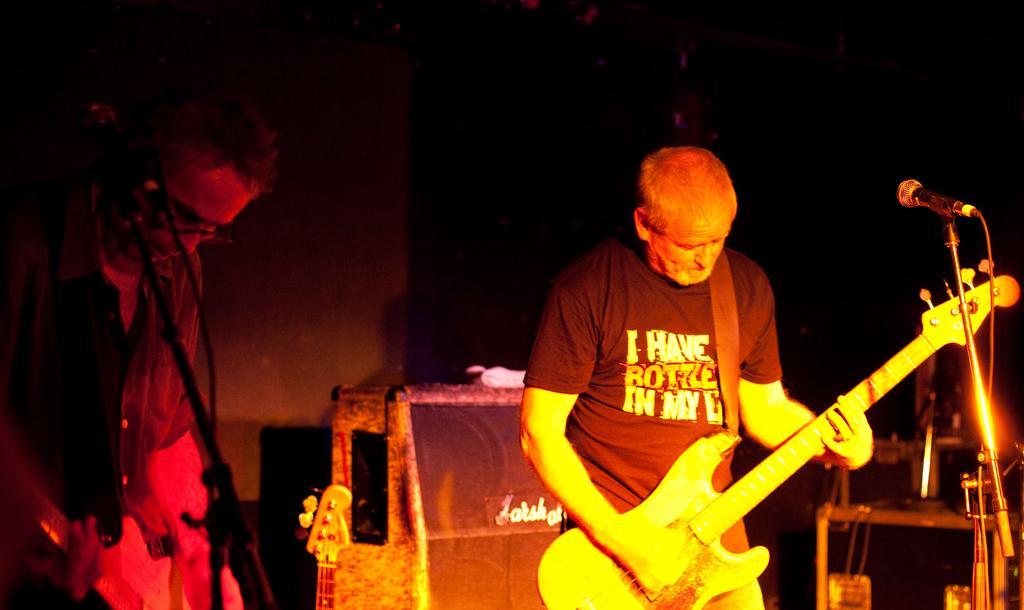How would you summarize this image in a sentence or two? Here we can see that a man is standing on the stage and playing guitar, and at side a person is standing, and here is the microphone and stand, and here there are some objects. 